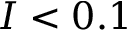<formula> <loc_0><loc_0><loc_500><loc_500>I < 0 . 1</formula> 